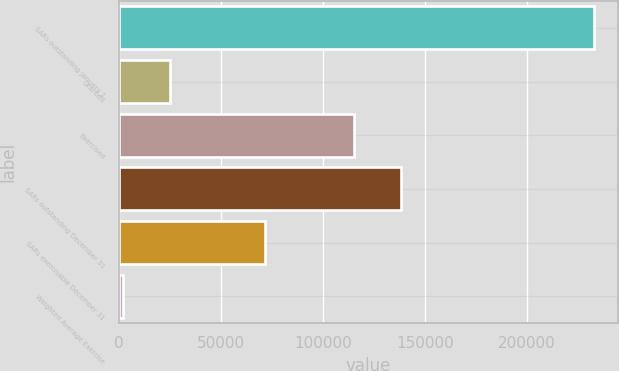<chart> <loc_0><loc_0><loc_500><loc_500><bar_chart><fcel>SARs outstanding January 1<fcel>Granted<fcel>Exercised<fcel>SARs outstanding December 31<fcel>SARs exercisable December 31<fcel>Weighted Average Exercise<nl><fcel>232930<fcel>25107.4<fcel>114976<fcel>138067<fcel>71701<fcel>2016<nl></chart> 